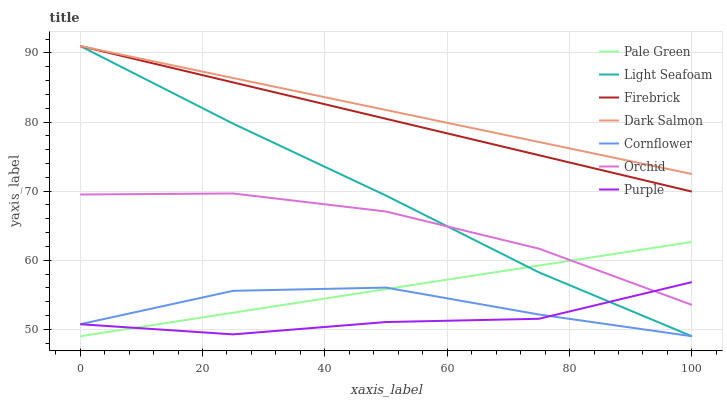Does Firebrick have the minimum area under the curve?
Answer yes or no. No. Does Firebrick have the maximum area under the curve?
Answer yes or no. No. Is Purple the smoothest?
Answer yes or no. No. Is Purple the roughest?
Answer yes or no. No. Does Purple have the lowest value?
Answer yes or no. No. Does Purple have the highest value?
Answer yes or no. No. Is Pale Green less than Dark Salmon?
Answer yes or no. Yes. Is Firebrick greater than Cornflower?
Answer yes or no. Yes. Does Pale Green intersect Dark Salmon?
Answer yes or no. No. 